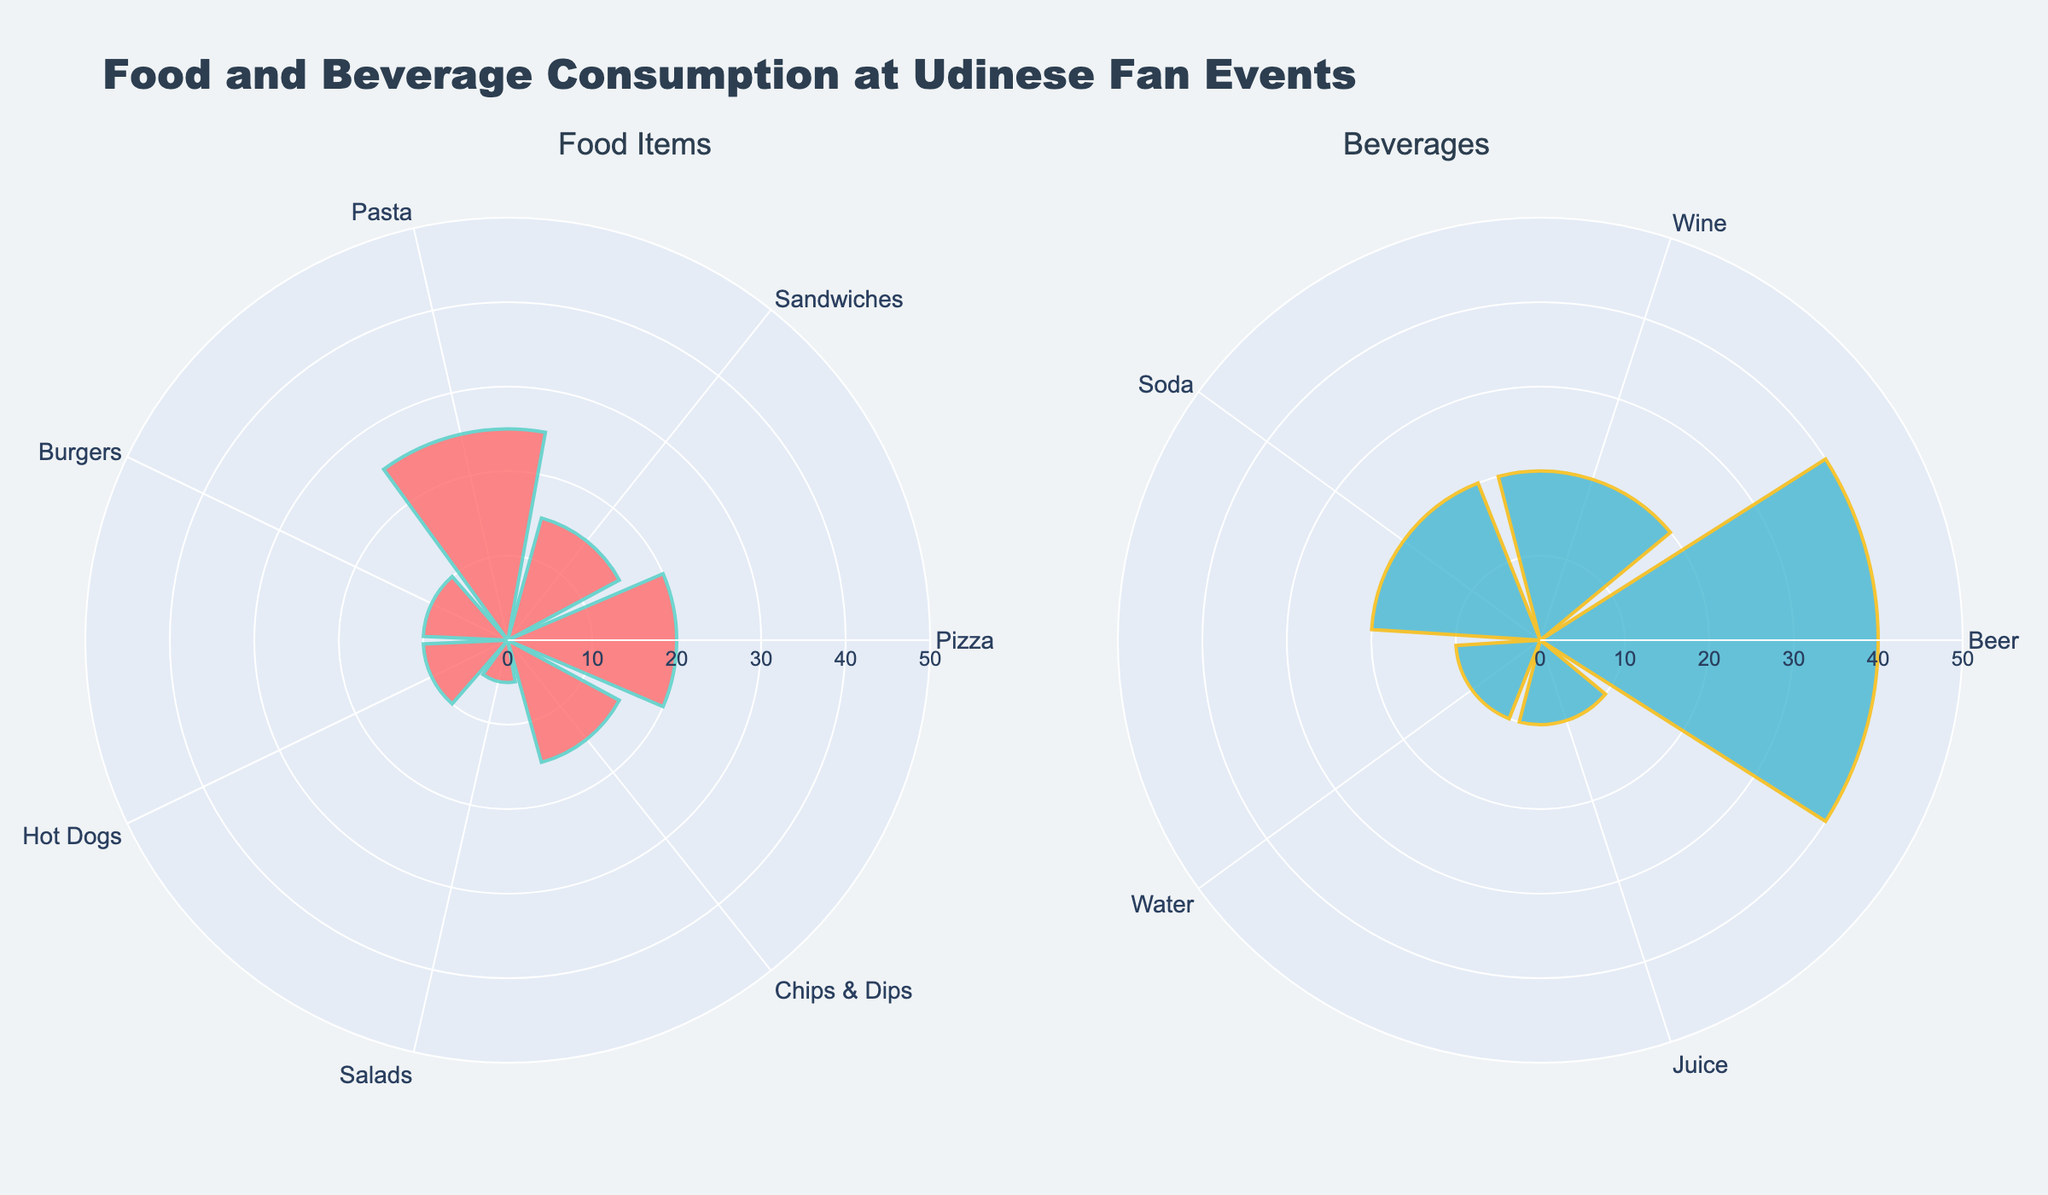What is the title of the chart? The title is displayed at the top of the figure, and it reads "Food and Beverage Consumption at Udinese Fan Events".
Answer: Food and Beverage Consumption at Udinese Fan Events Which food item has the highest percentage? The first subplot shows the food items as categories with their corresponding percentages. The item with the highest bar is "Pasta" with 25%.
Answer: Pasta How many food items are listed in the data? Count the number of distinct food items displayed in the first subplot.
Answer: 7 Which beverage holds the majority share? Observe the lengths of the bars in the second subplot of beverages. The item "Beer" has the highest percentage at 40%.
Answer: Beer What's the combined percentage of food items "Burgers" and "Hot Dogs"? Add the percentages corresponding to "Burgers" and "Hot Dogs". They are 10% each, so 10 + 10 = 20%.
Answer: 20% How does the percentage of sandwiches compare to that of salads? Look at the lengths of the bars for "Sandwiches" and "Salads". Sandwiches have 15%, while Salads have 5%. Sandwiches have a higher percentage.
Answer: Sandwiches have a higher percentage What is the total percentage for beverage items in the chart? Sum the percentages of all beverage items: Beer (40%), Wine (20%), Soda (20%), Water (10%), Juice (10%). The total is 40 + 20 + 20 + 10 + 10 = 100%.
Answer: 100% Which category, Food or Beverages, has the most items? Count the number of items in the food category and the beverage category. Food has 7 items, and Beverages have 5.
Answer: Food If we want to balance the percentages between food and beverages more equally, which category should we reduce or increase? Calculate the total percentage for both categories: Food (100%) and Beverages (100%). Since they are already equal, no change is needed. However, individual items could be adjusted for balance within each category.
Answer: No change needed What is the difference in percentages between the most and least consumed beverage items? Compare the highest percentage item (Beer at 40%) with the lowest percentage items (Water and Juice at 10%). Calculate the difference: 40 - 10 = 30%.
Answer: 30% 